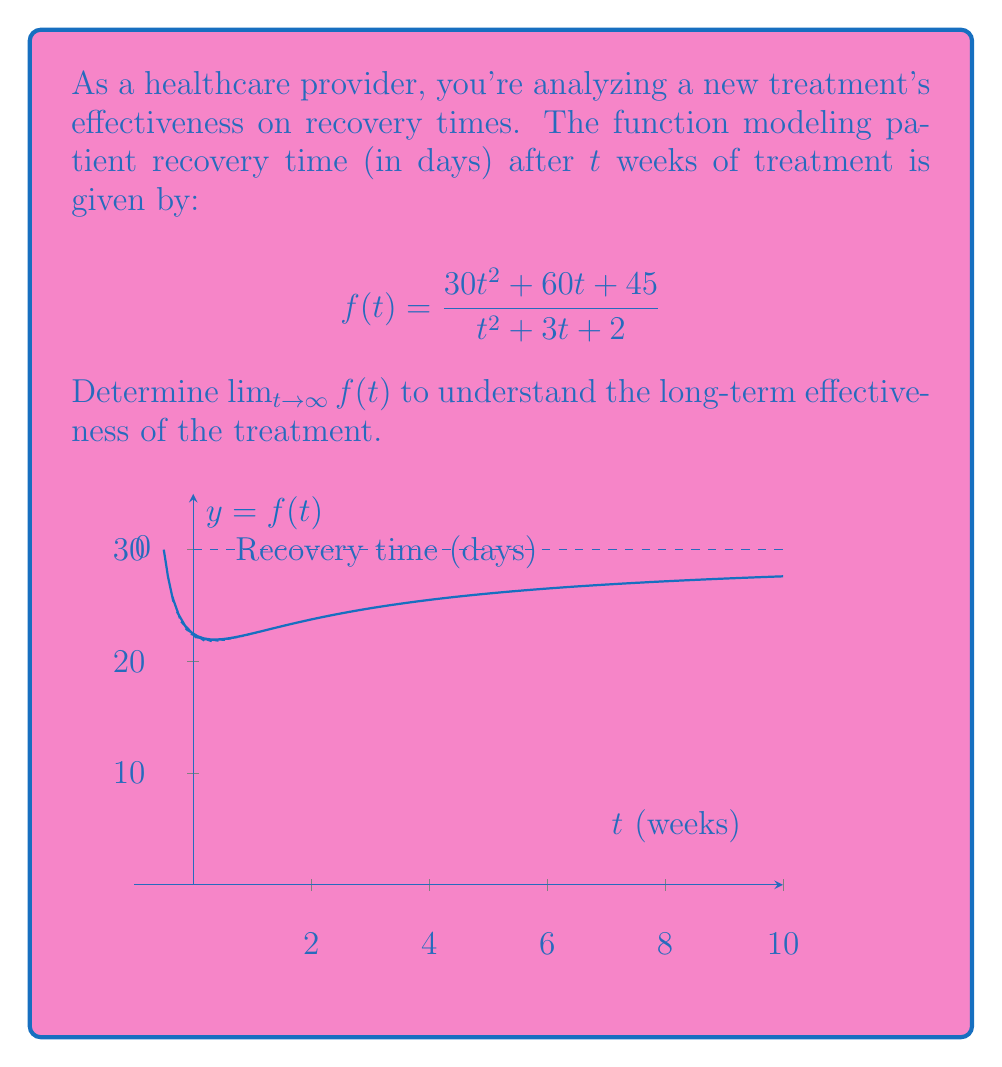Show me your answer to this math problem. To find $\lim_{t \to \infty} f(t)$, we'll use the following steps:

1) First, observe that both numerator and denominator are polynomials, and the degree of both is 2. This suggests that the limit will be the ratio of the leading coefficients.

2) Let's confirm this by dividing both numerator and denominator by the highest power of t (t^2):

   $$\lim_{t \to \infty} f(t) = \lim_{t \to \infty} \frac{30t^2 + 60t + 45}{t^2 + 3t + 2}$$
   
   $$= \lim_{t \to \infty} \frac{30 + \frac{60}{t} + \frac{45}{t^2}}{1 + \frac{3}{t} + \frac{2}{t^2}}$$

3) As t approaches infinity, the terms with t in the denominator approach 0:

   $$= \frac{30 + 0 + 0}{1 + 0 + 0} = 30$$

4) Therefore, the limit of the function as t approaches infinity is 30.

This means that as the treatment time increases indefinitely, the recovery time approaches 30 days, which represents the long-term effectiveness of the treatment.
Answer: 30 days 